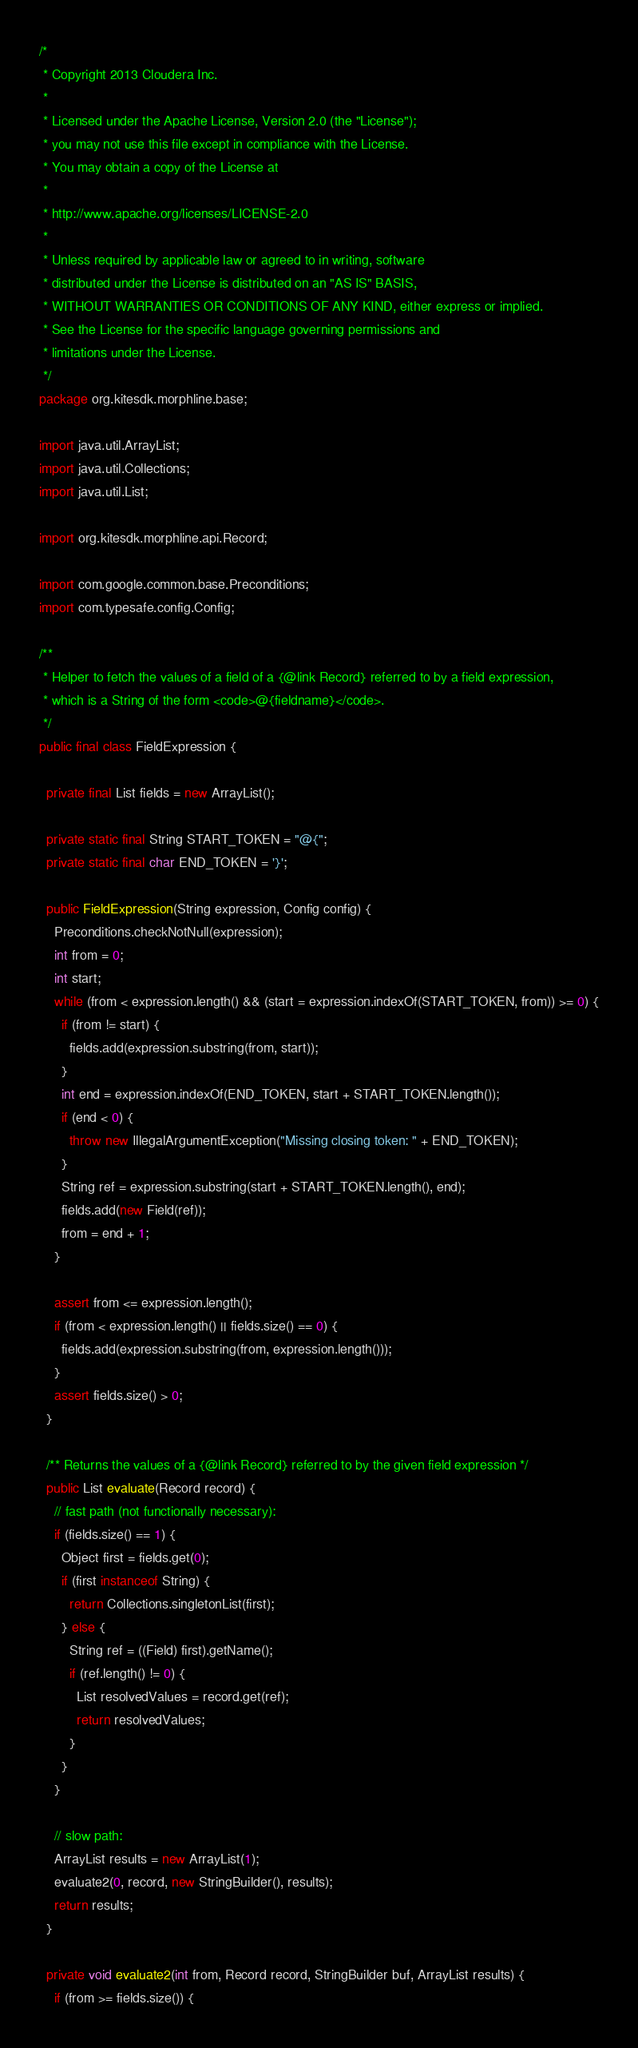Convert code to text. <code><loc_0><loc_0><loc_500><loc_500><_Java_>/*
 * Copyright 2013 Cloudera Inc.
 *
 * Licensed under the Apache License, Version 2.0 (the "License");
 * you may not use this file except in compliance with the License.
 * You may obtain a copy of the License at
 *
 * http://www.apache.org/licenses/LICENSE-2.0
 *
 * Unless required by applicable law or agreed to in writing, software
 * distributed under the License is distributed on an "AS IS" BASIS,
 * WITHOUT WARRANTIES OR CONDITIONS OF ANY KIND, either express or implied.
 * See the License for the specific language governing permissions and
 * limitations under the License.
 */
package org.kitesdk.morphline.base;

import java.util.ArrayList;
import java.util.Collections;
import java.util.List;

import org.kitesdk.morphline.api.Record;

import com.google.common.base.Preconditions;
import com.typesafe.config.Config;

/**
 * Helper to fetch the values of a field of a {@link Record} referred to by a field expression,
 * which is a String of the form <code>@{fieldname}</code>.
 */
public final class FieldExpression {
  
  private final List fields = new ArrayList();
  
  private static final String START_TOKEN = "@{";
  private static final char END_TOKEN = '}';
  
  public FieldExpression(String expression, Config config) {
    Preconditions.checkNotNull(expression);
    int from = 0;
    int start;
    while (from < expression.length() && (start = expression.indexOf(START_TOKEN, from)) >= 0) {
      if (from != start) {
        fields.add(expression.substring(from, start));
      }
      int end = expression.indexOf(END_TOKEN, start + START_TOKEN.length());
      if (end < 0) {
        throw new IllegalArgumentException("Missing closing token: " + END_TOKEN);
      }
      String ref = expression.substring(start + START_TOKEN.length(), end);
      fields.add(new Field(ref));
      from = end + 1;
    }
    
    assert from <= expression.length();
    if (from < expression.length() || fields.size() == 0) {
      fields.add(expression.substring(from, expression.length()));
    }
    assert fields.size() > 0;
  }
  
  /** Returns the values of a {@link Record} referred to by the given field expression */
  public List evaluate(Record record) {
    // fast path (not functionally necessary):
    if (fields.size() == 1) {
      Object first = fields.get(0);
      if (first instanceof String) {
        return Collections.singletonList(first);
      } else {
        String ref = ((Field) first).getName();
        if (ref.length() != 0) {
          List resolvedValues = record.get(ref);
          return resolvedValues;
        }
      }
    }

    // slow path:
    ArrayList results = new ArrayList(1);
    evaluate2(0, record, new StringBuilder(), results);
    return results;
  }

  private void evaluate2(int from, Record record, StringBuilder buf, ArrayList results) {
    if (from >= fields.size()) {</code> 